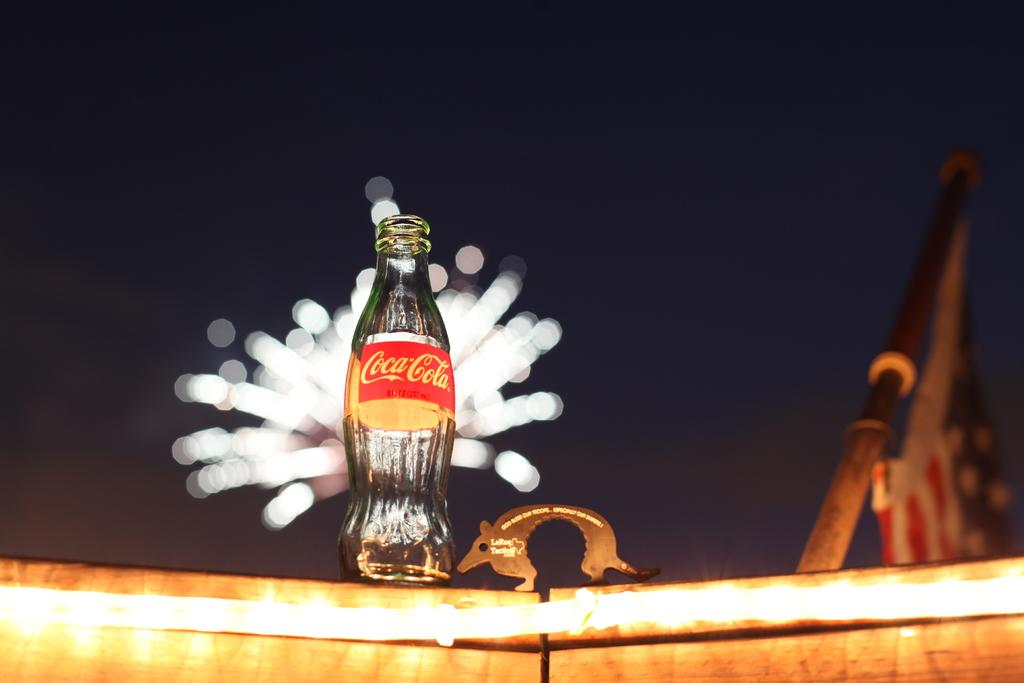Provide a one-sentence caption for the provided image. A bottle of Coca Cola sits on a boat railing in front of fireworks. 